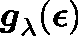<formula> <loc_0><loc_0><loc_500><loc_500>g _ { \lambda } ( \epsilon )</formula> 